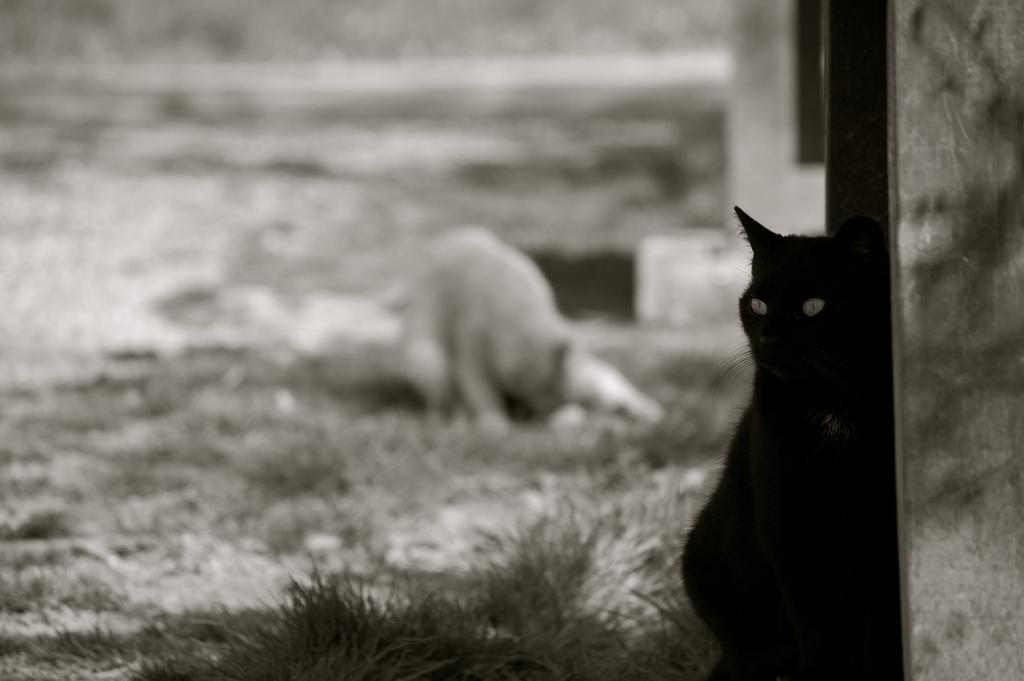How many cats are present in the image? There are two cats in the image. What type of surface can be seen in the image? There is grass visible in the image. What color is the umbrella that the cats are sitting under in the image? There is no umbrella present in the image; it only features two cats and grass. How do the cats express regret in the image? There is no indication of regret in the image, as cats do not have the ability to express emotions like regret. 